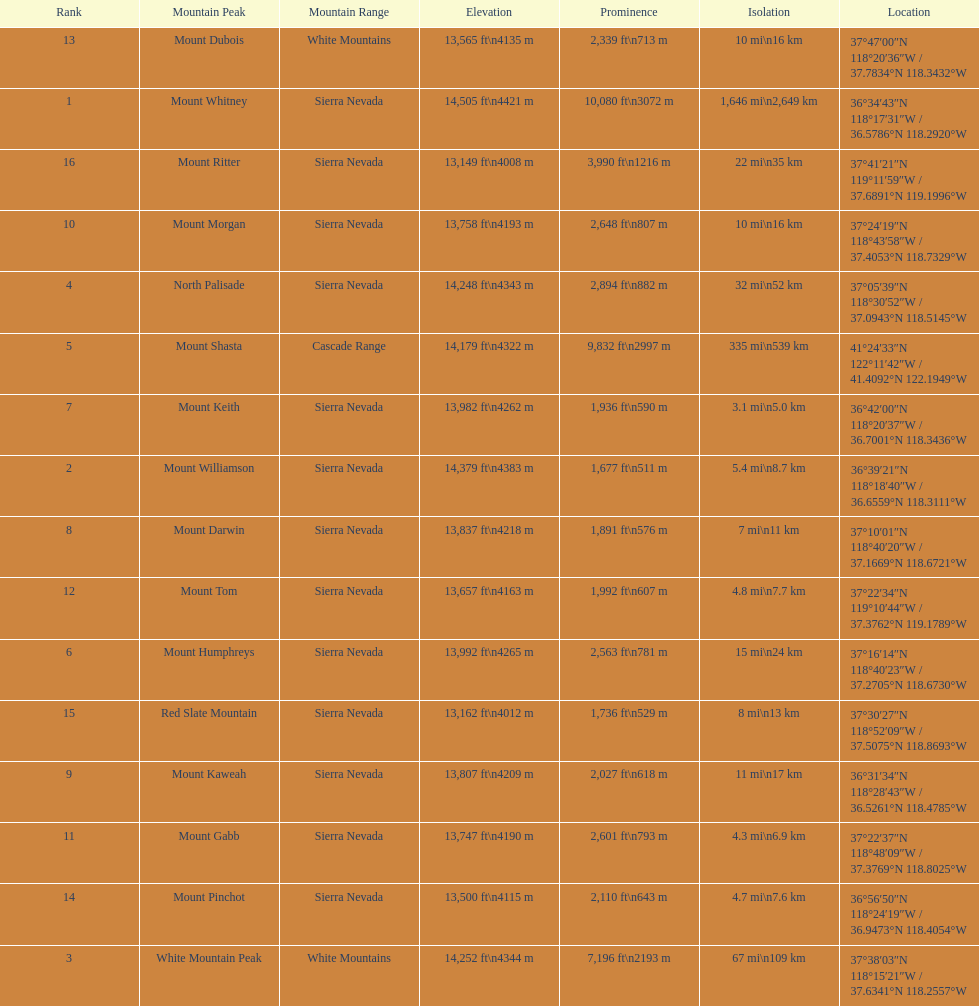How much taller is the mountain peak of mount williamson than that of mount keith? 397 ft. Would you be able to parse every entry in this table? {'header': ['Rank', 'Mountain Peak', 'Mountain Range', 'Elevation', 'Prominence', 'Isolation', 'Location'], 'rows': [['13', 'Mount Dubois', 'White Mountains', '13,565\xa0ft\\n4135\xa0m', '2,339\xa0ft\\n713\xa0m', '10\xa0mi\\n16\xa0km', '37°47′00″N 118°20′36″W\ufeff / \ufeff37.7834°N 118.3432°W'], ['1', 'Mount Whitney', 'Sierra Nevada', '14,505\xa0ft\\n4421\xa0m', '10,080\xa0ft\\n3072\xa0m', '1,646\xa0mi\\n2,649\xa0km', '36°34′43″N 118°17′31″W\ufeff / \ufeff36.5786°N 118.2920°W'], ['16', 'Mount Ritter', 'Sierra Nevada', '13,149\xa0ft\\n4008\xa0m', '3,990\xa0ft\\n1216\xa0m', '22\xa0mi\\n35\xa0km', '37°41′21″N 119°11′59″W\ufeff / \ufeff37.6891°N 119.1996°W'], ['10', 'Mount Morgan', 'Sierra Nevada', '13,758\xa0ft\\n4193\xa0m', '2,648\xa0ft\\n807\xa0m', '10\xa0mi\\n16\xa0km', '37°24′19″N 118°43′58″W\ufeff / \ufeff37.4053°N 118.7329°W'], ['4', 'North Palisade', 'Sierra Nevada', '14,248\xa0ft\\n4343\xa0m', '2,894\xa0ft\\n882\xa0m', '32\xa0mi\\n52\xa0km', '37°05′39″N 118°30′52″W\ufeff / \ufeff37.0943°N 118.5145°W'], ['5', 'Mount Shasta', 'Cascade Range', '14,179\xa0ft\\n4322\xa0m', '9,832\xa0ft\\n2997\xa0m', '335\xa0mi\\n539\xa0km', '41°24′33″N 122°11′42″W\ufeff / \ufeff41.4092°N 122.1949°W'], ['7', 'Mount Keith', 'Sierra Nevada', '13,982\xa0ft\\n4262\xa0m', '1,936\xa0ft\\n590\xa0m', '3.1\xa0mi\\n5.0\xa0km', '36°42′00″N 118°20′37″W\ufeff / \ufeff36.7001°N 118.3436°W'], ['2', 'Mount Williamson', 'Sierra Nevada', '14,379\xa0ft\\n4383\xa0m', '1,677\xa0ft\\n511\xa0m', '5.4\xa0mi\\n8.7\xa0km', '36°39′21″N 118°18′40″W\ufeff / \ufeff36.6559°N 118.3111°W'], ['8', 'Mount Darwin', 'Sierra Nevada', '13,837\xa0ft\\n4218\xa0m', '1,891\xa0ft\\n576\xa0m', '7\xa0mi\\n11\xa0km', '37°10′01″N 118°40′20″W\ufeff / \ufeff37.1669°N 118.6721°W'], ['12', 'Mount Tom', 'Sierra Nevada', '13,657\xa0ft\\n4163\xa0m', '1,992\xa0ft\\n607\xa0m', '4.8\xa0mi\\n7.7\xa0km', '37°22′34″N 119°10′44″W\ufeff / \ufeff37.3762°N 119.1789°W'], ['6', 'Mount Humphreys', 'Sierra Nevada', '13,992\xa0ft\\n4265\xa0m', '2,563\xa0ft\\n781\xa0m', '15\xa0mi\\n24\xa0km', '37°16′14″N 118°40′23″W\ufeff / \ufeff37.2705°N 118.6730°W'], ['15', 'Red Slate Mountain', 'Sierra Nevada', '13,162\xa0ft\\n4012\xa0m', '1,736\xa0ft\\n529\xa0m', '8\xa0mi\\n13\xa0km', '37°30′27″N 118°52′09″W\ufeff / \ufeff37.5075°N 118.8693°W'], ['9', 'Mount Kaweah', 'Sierra Nevada', '13,807\xa0ft\\n4209\xa0m', '2,027\xa0ft\\n618\xa0m', '11\xa0mi\\n17\xa0km', '36°31′34″N 118°28′43″W\ufeff / \ufeff36.5261°N 118.4785°W'], ['11', 'Mount Gabb', 'Sierra Nevada', '13,747\xa0ft\\n4190\xa0m', '2,601\xa0ft\\n793\xa0m', '4.3\xa0mi\\n6.9\xa0km', '37°22′37″N 118°48′09″W\ufeff / \ufeff37.3769°N 118.8025°W'], ['14', 'Mount Pinchot', 'Sierra Nevada', '13,500\xa0ft\\n4115\xa0m', '2,110\xa0ft\\n643\xa0m', '4.7\xa0mi\\n7.6\xa0km', '36°56′50″N 118°24′19″W\ufeff / \ufeff36.9473°N 118.4054°W'], ['3', 'White Mountain Peak', 'White Mountains', '14,252\xa0ft\\n4344\xa0m', '7,196\xa0ft\\n2193\xa0m', '67\xa0mi\\n109\xa0km', '37°38′03″N 118°15′21″W\ufeff / \ufeff37.6341°N 118.2557°W']]} 